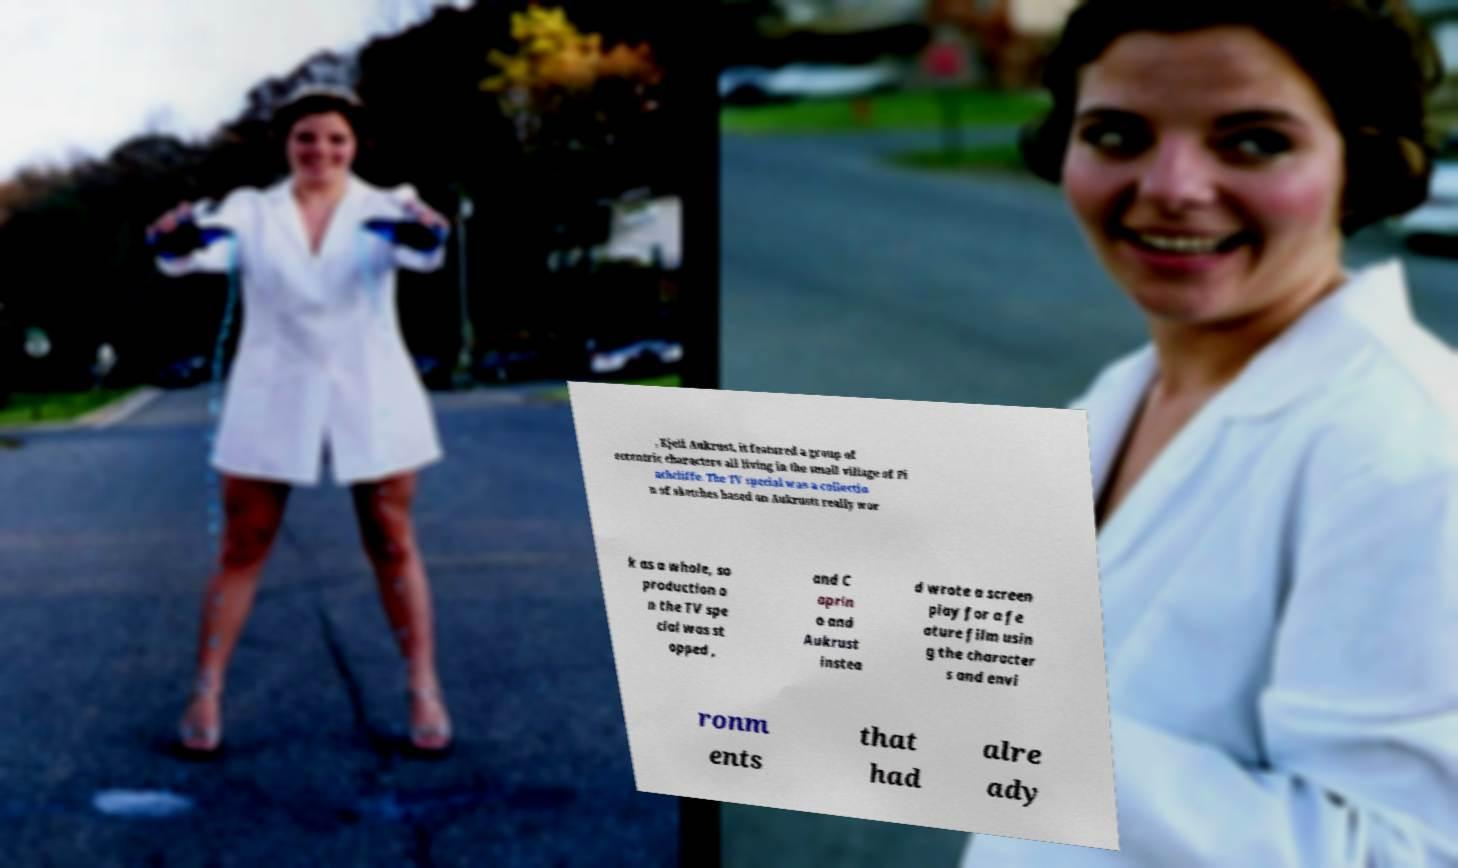Could you assist in decoding the text presented in this image and type it out clearly? , Kjell Aukrust, it featured a group of eccentric characters all living in the small village of Pi nchcliffe. The TV special was a collectio n of sketches based on Aukrustt really wor k as a whole, so production o n the TV spe cial was st opped , and C aprin o and Aukrust instea d wrote a screen play for a fe ature film usin g the character s and envi ronm ents that had alre ady 